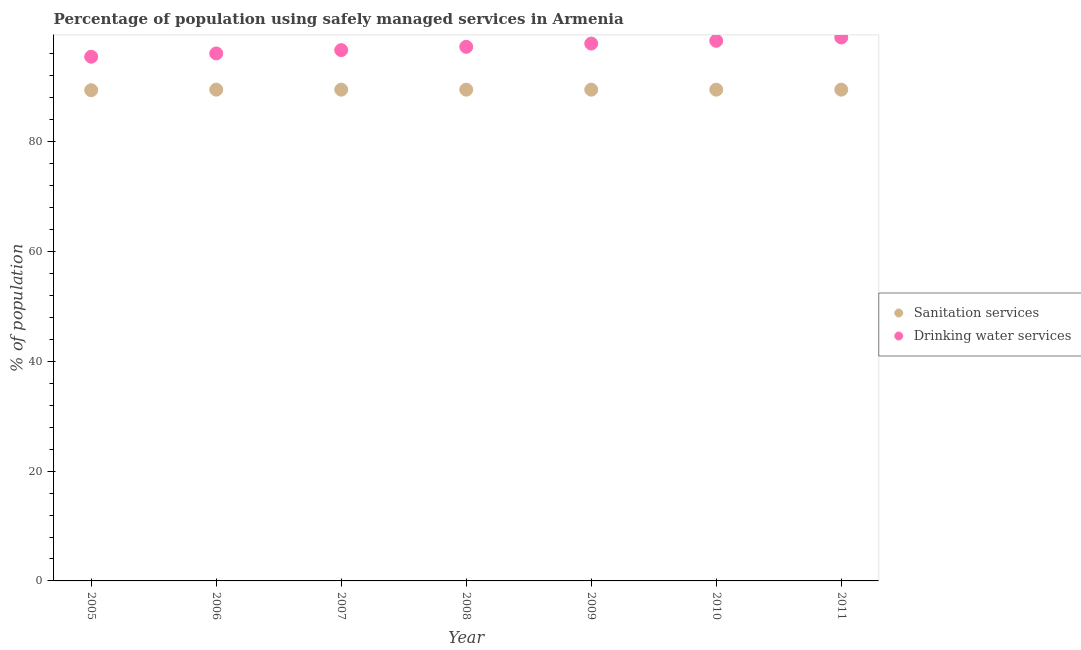What is the percentage of population who used drinking water services in 2006?
Make the answer very short. 96.1. Across all years, what is the maximum percentage of population who used drinking water services?
Make the answer very short. 99. Across all years, what is the minimum percentage of population who used sanitation services?
Offer a very short reply. 89.4. In which year was the percentage of population who used sanitation services maximum?
Your response must be concise. 2006. What is the total percentage of population who used drinking water services in the graph?
Your answer should be very brief. 680.9. What is the difference between the percentage of population who used drinking water services in 2007 and the percentage of population who used sanitation services in 2006?
Offer a terse response. 7.2. What is the average percentage of population who used sanitation services per year?
Your response must be concise. 89.49. In the year 2005, what is the difference between the percentage of population who used sanitation services and percentage of population who used drinking water services?
Ensure brevity in your answer.  -6.1. In how many years, is the percentage of population who used drinking water services greater than 8 %?
Offer a terse response. 7. What is the ratio of the percentage of population who used drinking water services in 2007 to that in 2009?
Your answer should be very brief. 0.99. Is the percentage of population who used sanitation services in 2006 less than that in 2011?
Your answer should be very brief. No. Is the difference between the percentage of population who used drinking water services in 2005 and 2011 greater than the difference between the percentage of population who used sanitation services in 2005 and 2011?
Offer a very short reply. No. What is the difference between the highest and the second highest percentage of population who used sanitation services?
Your response must be concise. 0. In how many years, is the percentage of population who used drinking water services greater than the average percentage of population who used drinking water services taken over all years?
Keep it short and to the point. 4. Is the sum of the percentage of population who used drinking water services in 2009 and 2011 greater than the maximum percentage of population who used sanitation services across all years?
Ensure brevity in your answer.  Yes. Does the percentage of population who used drinking water services monotonically increase over the years?
Provide a short and direct response. Yes. Is the percentage of population who used sanitation services strictly greater than the percentage of population who used drinking water services over the years?
Your answer should be compact. No. How many dotlines are there?
Provide a succinct answer. 2. How many years are there in the graph?
Your response must be concise. 7. What is the difference between two consecutive major ticks on the Y-axis?
Make the answer very short. 20. How are the legend labels stacked?
Give a very brief answer. Vertical. What is the title of the graph?
Provide a short and direct response. Percentage of population using safely managed services in Armenia. What is the label or title of the Y-axis?
Ensure brevity in your answer.  % of population. What is the % of population of Sanitation services in 2005?
Offer a very short reply. 89.4. What is the % of population of Drinking water services in 2005?
Offer a very short reply. 95.5. What is the % of population in Sanitation services in 2006?
Provide a short and direct response. 89.5. What is the % of population in Drinking water services in 2006?
Offer a very short reply. 96.1. What is the % of population in Sanitation services in 2007?
Your answer should be compact. 89.5. What is the % of population in Drinking water services in 2007?
Provide a short and direct response. 96.7. What is the % of population of Sanitation services in 2008?
Provide a succinct answer. 89.5. What is the % of population in Drinking water services in 2008?
Keep it short and to the point. 97.3. What is the % of population in Sanitation services in 2009?
Provide a short and direct response. 89.5. What is the % of population of Drinking water services in 2009?
Provide a succinct answer. 97.9. What is the % of population of Sanitation services in 2010?
Provide a succinct answer. 89.5. What is the % of population of Drinking water services in 2010?
Offer a very short reply. 98.4. What is the % of population in Sanitation services in 2011?
Offer a very short reply. 89.5. What is the % of population in Drinking water services in 2011?
Make the answer very short. 99. Across all years, what is the maximum % of population of Sanitation services?
Provide a short and direct response. 89.5. Across all years, what is the minimum % of population in Sanitation services?
Provide a succinct answer. 89.4. Across all years, what is the minimum % of population in Drinking water services?
Your response must be concise. 95.5. What is the total % of population of Sanitation services in the graph?
Give a very brief answer. 626.4. What is the total % of population in Drinking water services in the graph?
Provide a short and direct response. 680.9. What is the difference between the % of population of Drinking water services in 2005 and that in 2006?
Your response must be concise. -0.6. What is the difference between the % of population of Drinking water services in 2005 and that in 2007?
Give a very brief answer. -1.2. What is the difference between the % of population in Sanitation services in 2005 and that in 2008?
Make the answer very short. -0.1. What is the difference between the % of population in Drinking water services in 2005 and that in 2009?
Offer a very short reply. -2.4. What is the difference between the % of population of Drinking water services in 2005 and that in 2010?
Make the answer very short. -2.9. What is the difference between the % of population of Drinking water services in 2005 and that in 2011?
Give a very brief answer. -3.5. What is the difference between the % of population in Sanitation services in 2006 and that in 2007?
Give a very brief answer. 0. What is the difference between the % of population of Drinking water services in 2006 and that in 2007?
Ensure brevity in your answer.  -0.6. What is the difference between the % of population in Sanitation services in 2006 and that in 2008?
Ensure brevity in your answer.  0. What is the difference between the % of population in Drinking water services in 2006 and that in 2008?
Provide a succinct answer. -1.2. What is the difference between the % of population in Sanitation services in 2006 and that in 2010?
Keep it short and to the point. 0. What is the difference between the % of population in Sanitation services in 2006 and that in 2011?
Make the answer very short. 0. What is the difference between the % of population in Sanitation services in 2007 and that in 2009?
Offer a terse response. 0. What is the difference between the % of population of Drinking water services in 2007 and that in 2011?
Keep it short and to the point. -2.3. What is the difference between the % of population in Sanitation services in 2008 and that in 2011?
Make the answer very short. 0. What is the difference between the % of population in Drinking water services in 2008 and that in 2011?
Keep it short and to the point. -1.7. What is the difference between the % of population in Drinking water services in 2009 and that in 2011?
Make the answer very short. -1.1. What is the difference between the % of population of Sanitation services in 2010 and that in 2011?
Offer a terse response. 0. What is the difference between the % of population in Sanitation services in 2005 and the % of population in Drinking water services in 2007?
Provide a short and direct response. -7.3. What is the difference between the % of population in Sanitation services in 2005 and the % of population in Drinking water services in 2009?
Your response must be concise. -8.5. What is the difference between the % of population in Sanitation services in 2006 and the % of population in Drinking water services in 2007?
Your response must be concise. -7.2. What is the difference between the % of population of Sanitation services in 2006 and the % of population of Drinking water services in 2008?
Offer a very short reply. -7.8. What is the difference between the % of population in Sanitation services in 2006 and the % of population in Drinking water services in 2010?
Give a very brief answer. -8.9. What is the difference between the % of population of Sanitation services in 2006 and the % of population of Drinking water services in 2011?
Your response must be concise. -9.5. What is the difference between the % of population in Sanitation services in 2007 and the % of population in Drinking water services in 2008?
Offer a terse response. -7.8. What is the difference between the % of population in Sanitation services in 2007 and the % of population in Drinking water services in 2009?
Keep it short and to the point. -8.4. What is the difference between the % of population in Sanitation services in 2007 and the % of population in Drinking water services in 2010?
Ensure brevity in your answer.  -8.9. What is the difference between the % of population in Sanitation services in 2007 and the % of population in Drinking water services in 2011?
Keep it short and to the point. -9.5. What is the difference between the % of population of Sanitation services in 2008 and the % of population of Drinking water services in 2010?
Your answer should be very brief. -8.9. What is the average % of population in Sanitation services per year?
Offer a terse response. 89.49. What is the average % of population of Drinking water services per year?
Provide a succinct answer. 97.27. In the year 2005, what is the difference between the % of population in Sanitation services and % of population in Drinking water services?
Offer a terse response. -6.1. In the year 2006, what is the difference between the % of population in Sanitation services and % of population in Drinking water services?
Offer a very short reply. -6.6. In the year 2007, what is the difference between the % of population in Sanitation services and % of population in Drinking water services?
Provide a short and direct response. -7.2. In the year 2008, what is the difference between the % of population of Sanitation services and % of population of Drinking water services?
Your answer should be compact. -7.8. In the year 2009, what is the difference between the % of population in Sanitation services and % of population in Drinking water services?
Provide a short and direct response. -8.4. In the year 2010, what is the difference between the % of population in Sanitation services and % of population in Drinking water services?
Keep it short and to the point. -8.9. What is the ratio of the % of population of Drinking water services in 2005 to that in 2007?
Your answer should be very brief. 0.99. What is the ratio of the % of population in Drinking water services in 2005 to that in 2008?
Your response must be concise. 0.98. What is the ratio of the % of population in Drinking water services in 2005 to that in 2009?
Your answer should be compact. 0.98. What is the ratio of the % of population of Drinking water services in 2005 to that in 2010?
Offer a terse response. 0.97. What is the ratio of the % of population of Sanitation services in 2005 to that in 2011?
Your answer should be compact. 1. What is the ratio of the % of population in Drinking water services in 2005 to that in 2011?
Provide a succinct answer. 0.96. What is the ratio of the % of population of Drinking water services in 2006 to that in 2008?
Your response must be concise. 0.99. What is the ratio of the % of population of Drinking water services in 2006 to that in 2009?
Make the answer very short. 0.98. What is the ratio of the % of population in Sanitation services in 2006 to that in 2010?
Provide a short and direct response. 1. What is the ratio of the % of population in Drinking water services in 2006 to that in 2010?
Give a very brief answer. 0.98. What is the ratio of the % of population in Sanitation services in 2006 to that in 2011?
Ensure brevity in your answer.  1. What is the ratio of the % of population of Drinking water services in 2006 to that in 2011?
Make the answer very short. 0.97. What is the ratio of the % of population in Drinking water services in 2007 to that in 2008?
Your answer should be very brief. 0.99. What is the ratio of the % of population in Sanitation services in 2007 to that in 2009?
Your response must be concise. 1. What is the ratio of the % of population of Drinking water services in 2007 to that in 2009?
Your answer should be compact. 0.99. What is the ratio of the % of population of Drinking water services in 2007 to that in 2010?
Your response must be concise. 0.98. What is the ratio of the % of population of Sanitation services in 2007 to that in 2011?
Make the answer very short. 1. What is the ratio of the % of population of Drinking water services in 2007 to that in 2011?
Your answer should be very brief. 0.98. What is the ratio of the % of population in Sanitation services in 2008 to that in 2009?
Your response must be concise. 1. What is the ratio of the % of population of Drinking water services in 2008 to that in 2009?
Your answer should be compact. 0.99. What is the ratio of the % of population of Sanitation services in 2008 to that in 2010?
Your answer should be very brief. 1. What is the ratio of the % of population in Sanitation services in 2008 to that in 2011?
Make the answer very short. 1. What is the ratio of the % of population of Drinking water services in 2008 to that in 2011?
Your response must be concise. 0.98. What is the ratio of the % of population of Drinking water services in 2009 to that in 2010?
Make the answer very short. 0.99. What is the ratio of the % of population of Drinking water services in 2009 to that in 2011?
Provide a succinct answer. 0.99. What is the difference between the highest and the second highest % of population in Sanitation services?
Offer a terse response. 0. What is the difference between the highest and the second highest % of population of Drinking water services?
Your response must be concise. 0.6. What is the difference between the highest and the lowest % of population in Sanitation services?
Give a very brief answer. 0.1. What is the difference between the highest and the lowest % of population of Drinking water services?
Your answer should be compact. 3.5. 